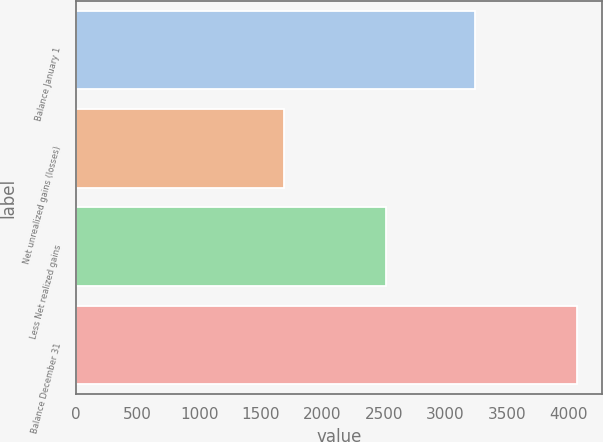Convert chart. <chart><loc_0><loc_0><loc_500><loc_500><bar_chart><fcel>Balance January 1<fcel>Net unrealized gains (losses)<fcel>Less Net realized gains<fcel>Balance December 31<nl><fcel>3242<fcel>1691<fcel>2513<fcel>4064<nl></chart> 